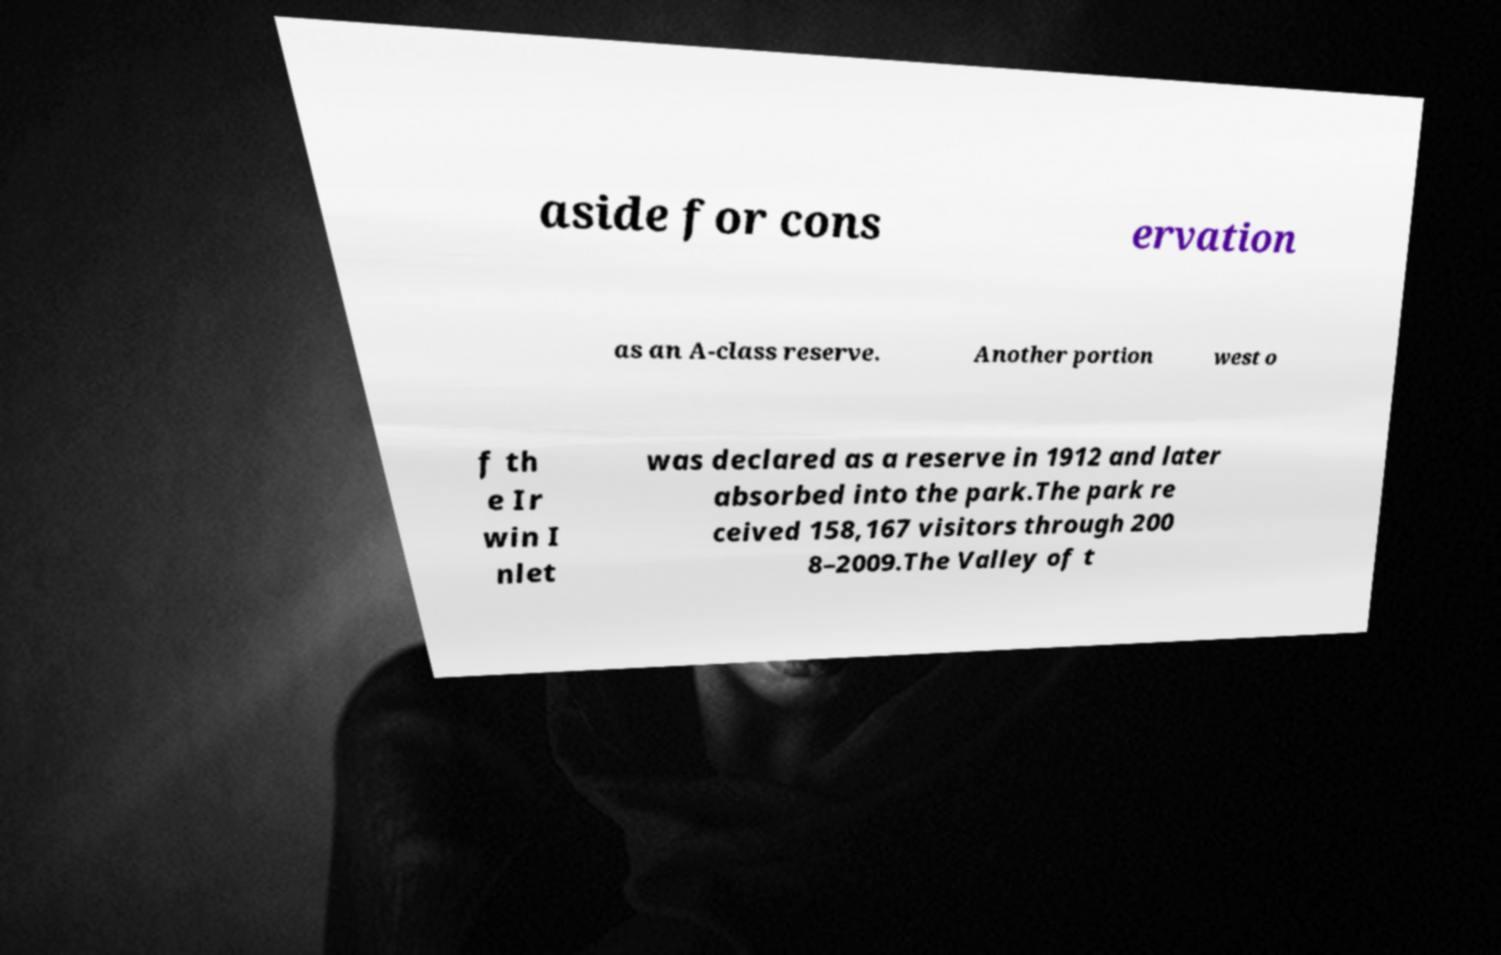There's text embedded in this image that I need extracted. Can you transcribe it verbatim? aside for cons ervation as an A-class reserve. Another portion west o f th e Ir win I nlet was declared as a reserve in 1912 and later absorbed into the park.The park re ceived 158,167 visitors through 200 8–2009.The Valley of t 